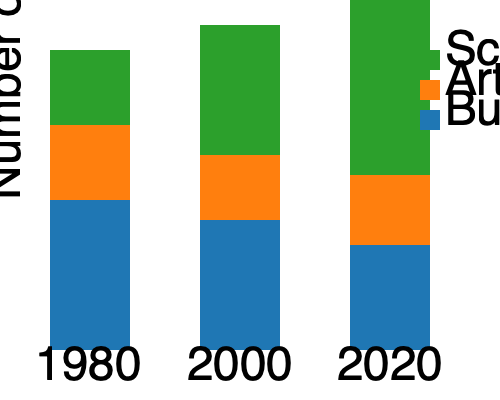Based on the stacked bar chart showing the distribution of academic departments at DMU over time, which department has shown the most significant growth in terms of number of departments from 1980 to 2020? To determine which department has shown the most significant growth from 1980 to 2020, we need to compare the increase in the number of departments for each category:

1. Science (green):
   1980: 3 departments
   2020: 7 departments
   Increase: 7 - 3 = 4 departments

2. Arts (orange):
   1980: 3 departments
   2020: 3 departments
   Increase: 3 - 3 = 0 departments

3. Business (blue):
   1980: 6 departments
   2020: 4 departments
   Increase: 4 - 6 = -2 departments (decrease)

Comparing the increases:
Science: +4
Arts: 0
Business: -2

The department with the most significant growth is Science, with an increase of 4 departments from 1980 to 2020.
Answer: Science 